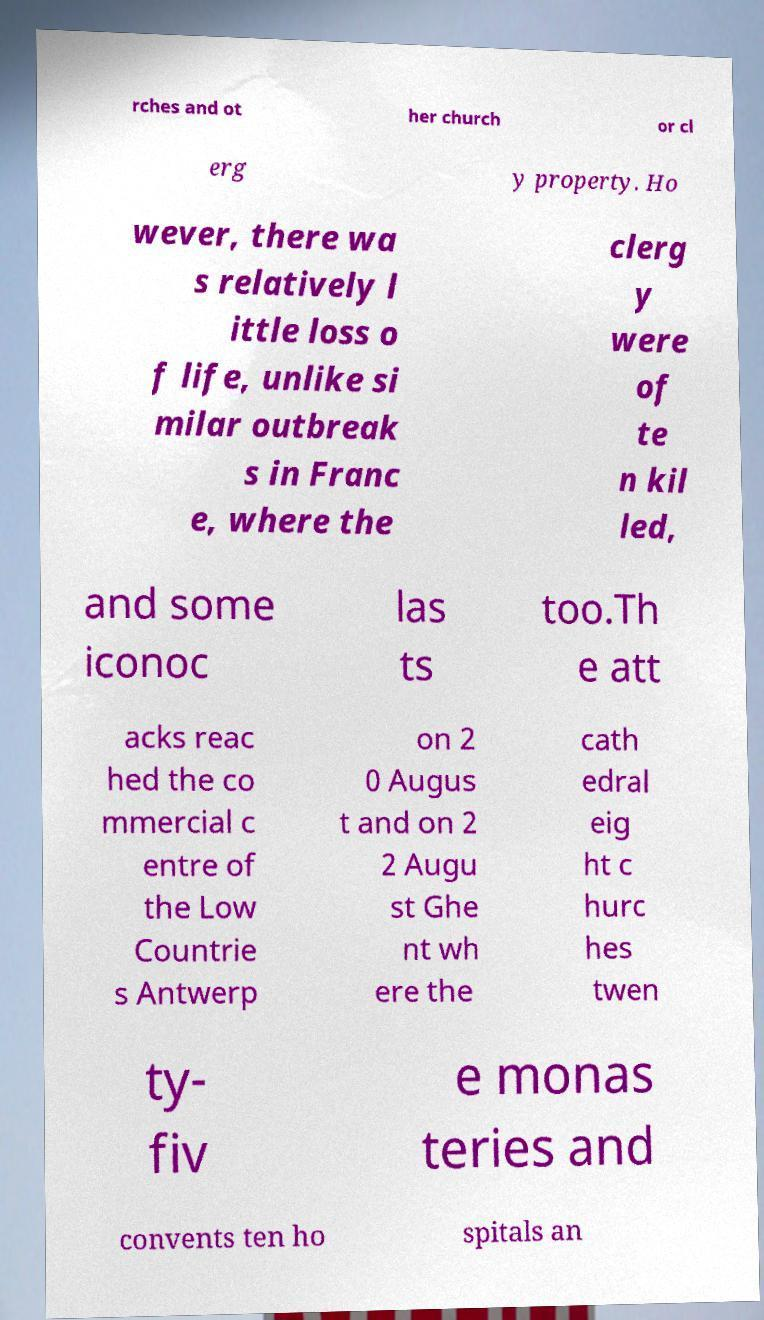Can you read and provide the text displayed in the image?This photo seems to have some interesting text. Can you extract and type it out for me? rches and ot her church or cl erg y property. Ho wever, there wa s relatively l ittle loss o f life, unlike si milar outbreak s in Franc e, where the clerg y were of te n kil led, and some iconoc las ts too.Th e att acks reac hed the co mmercial c entre of the Low Countrie s Antwerp on 2 0 Augus t and on 2 2 Augu st Ghe nt wh ere the cath edral eig ht c hurc hes twen ty- fiv e monas teries and convents ten ho spitals an 